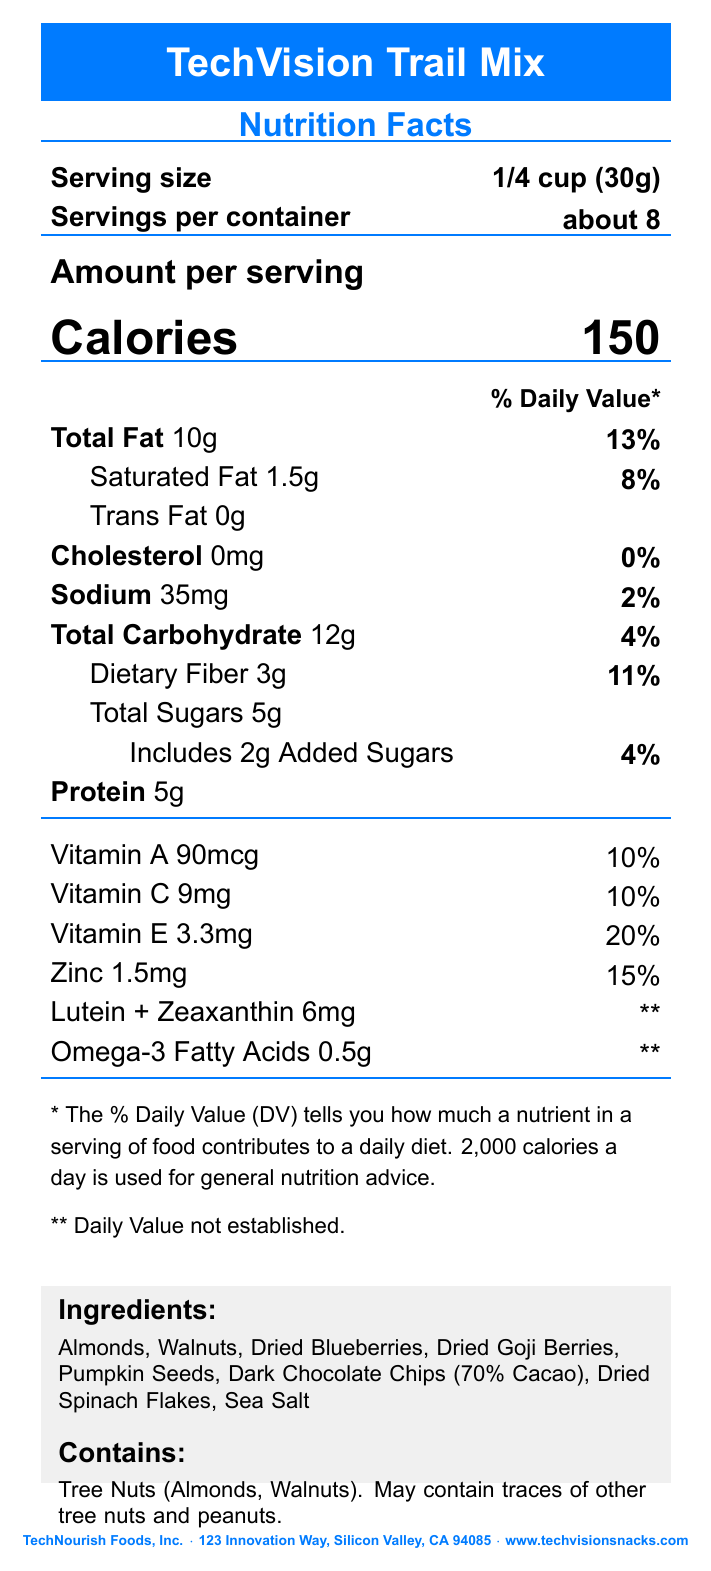what is the serving size? The serving size is listed at the top section of the document under the "Serving size" heading.
Answer: 1/4 cup (30g) how many calories are there per serving? The number of calories per serving is listed prominently in the center of the document.
Answer: 150 what are the total fat and its daily value percentage? These values are listed under "Total Fat" in the nutrition facts section.
Answer: 10g and 13% how much vitamin E does the trail mix provide per serving? The amount and daily value percentage of Vitamin E are listed in the vitamins section.
Answer: 3.3mg and 20% how many grams of dietary fiber are there per serving? The grams of dietary fiber per serving is listed under "Total Carbohydrate."
Answer: 3g which ingredients in the trail mix support eye health according to the health claims? The health claims section mentions Vitamin E, Lutein, Zeaxanthin, and Omega-3 fatty acids as supporting eye health.
Answer: Vitamin E, Lutein, Zeaxanthin, Omega-3 fatty acids how much sodium does the trail mix contain per serving and what is the daily value percentage? These values are listed under "Sodium" in the nutrition facts section.
Answer: 35mg and 2% does this trail mix contain any cholesterol? The cholesterol content is listed as 0mg in the nutrition facts section.
Answer: No, it contains 0mg cholesterol. what allergens are contained in the trail mix? The allergen information states that the trail mix contains tree nuts (Almonds, Walnuts).
Answer: Tree nuts (Almonds, Walnuts) what are the ingredients in the TechVision Trail Mix? The ingredients are listed in the "Ingredients" section on the bottom of the document.
Answer: Almonds, Walnuts, Dried Blueberries, Dried Goji Berries, Pumpkin Seeds, Dark Chocolate Chips (70% Cacao), Dried Spinach Flakes, Sea Salt how many servings are there per container? A. 6 B. about 8 C. 10 The serving per container is listed as "about 8" in the "Servings per container" section.
Answer: B how much protein is in one serving of TechVision Trail Mix? A. 4g B. 5g C. 6g The protein content per serving is listed as 5g in the nutrition facts section.
Answer: B does the trail mix contain any added sugars? The amount of added sugars is listed under "Total Sugars."
Answer: Yes, it includes 2g of added sugars. is the trail mix a good source of Vitamin C? The trail mix provides 10% of the daily value of Vitamin C per serving, which is generally considered a good source.
Answer: Yes does the product contain any artificial preservatives? No information is provided regarding artificial preservatives in the document.
Answer: Cannot be determined summarize the key points of the TechVision Trail Mix's nutrition facts label. The nutrition facts label provides detailed information about the nutrients in each serving, includes specific health benefits, lists the ingredients, and highlights potential allergens.
Answer: TechVision Trail Mix contains 150 calories per 1/4 cup serving, with 10g of total fat and 5g of protein. It is rich in antioxidants such as Vitamin E, Lutein, and Zeaxanthin which support eye health, and includes ingredients like almonds, walnuts, and dried berries. It also provides Omega-3 fatty acids to support retinal function. 